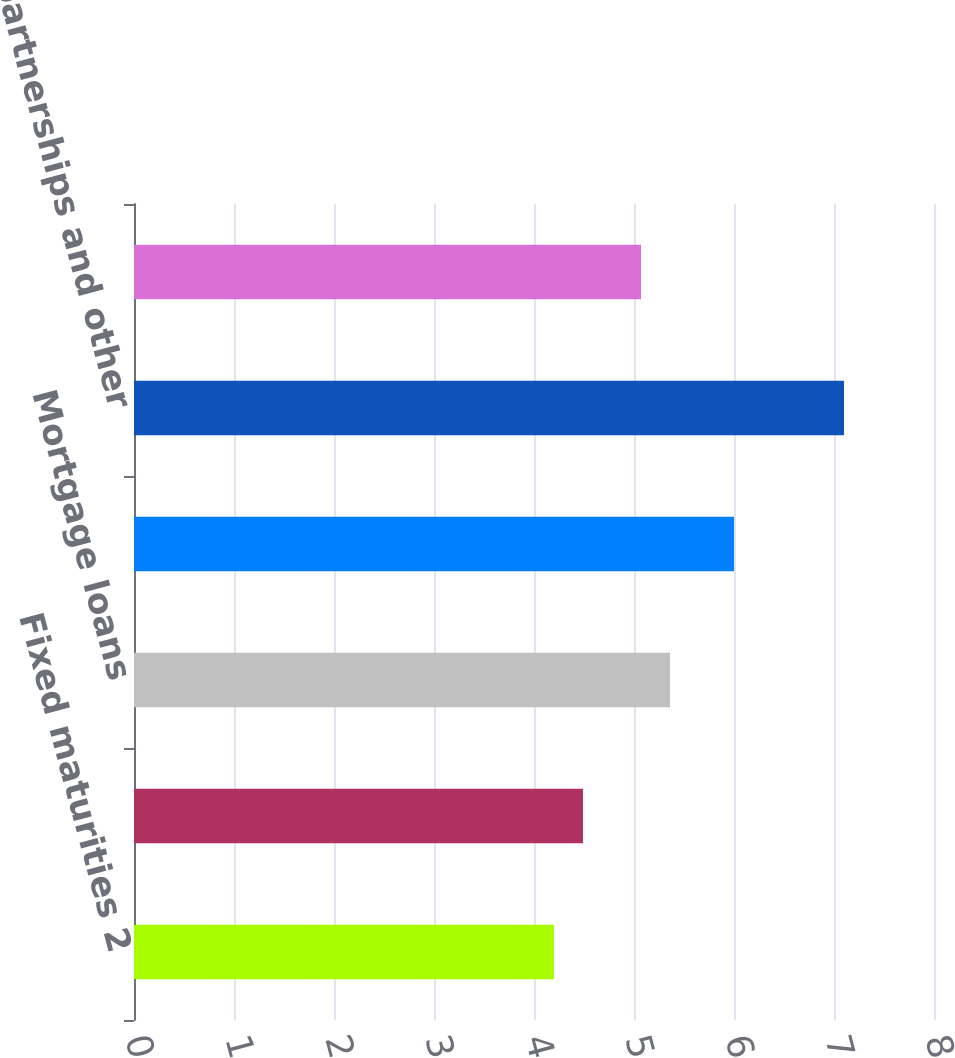Convert chart to OTSL. <chart><loc_0><loc_0><loc_500><loc_500><bar_chart><fcel>Fixed maturities 2<fcel>Equity securities AFS<fcel>Mortgage loans<fcel>Policy loans<fcel>Limited partnerships and other<fcel>Total securities AFS and other<nl><fcel>4.2<fcel>4.49<fcel>5.36<fcel>6<fcel>7.1<fcel>5.07<nl></chart> 